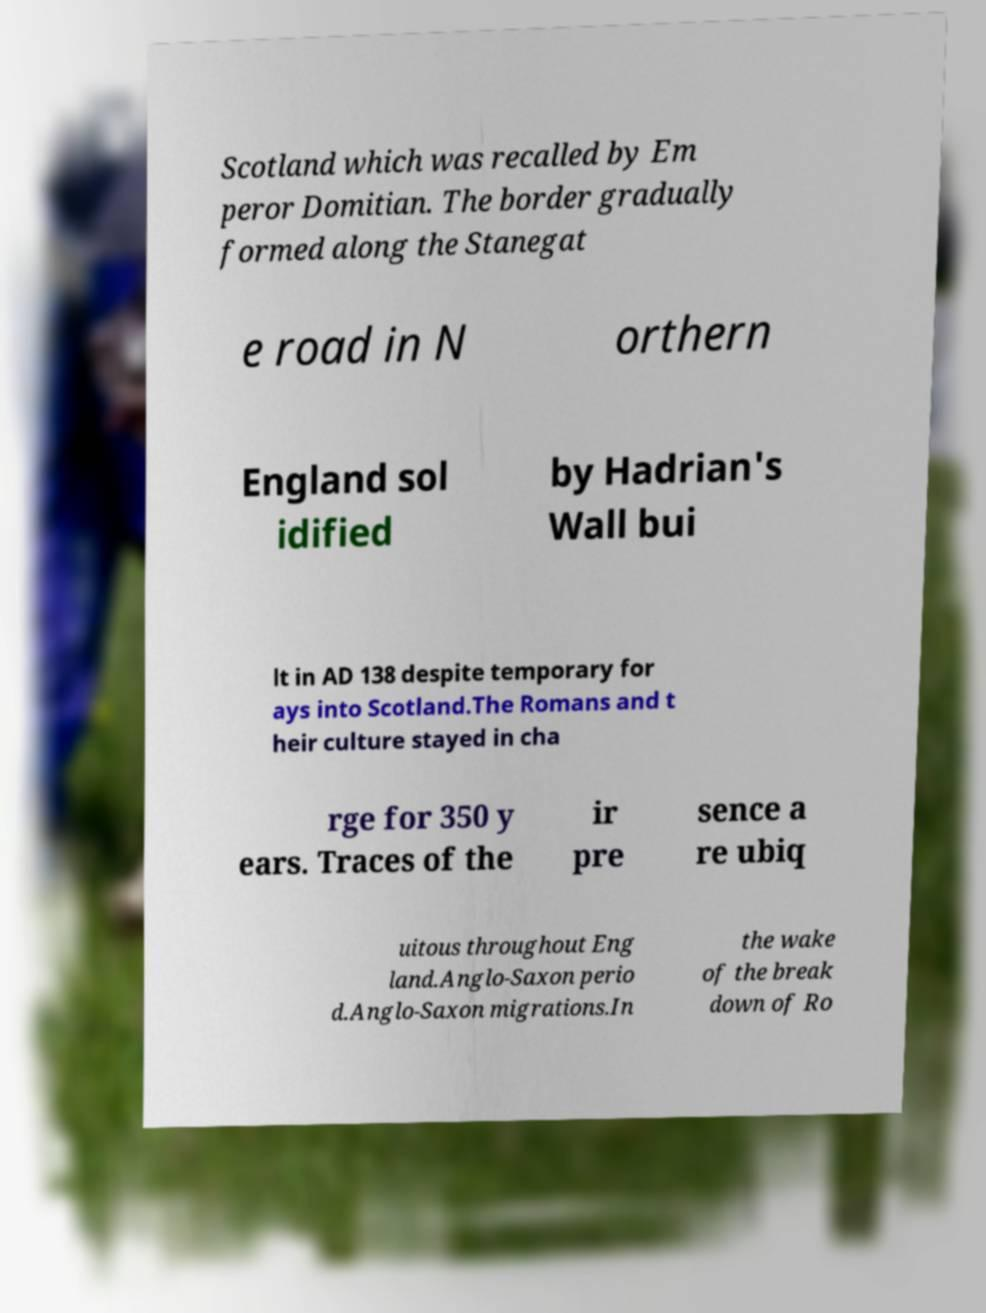There's text embedded in this image that I need extracted. Can you transcribe it verbatim? Scotland which was recalled by Em peror Domitian. The border gradually formed along the Stanegat e road in N orthern England sol idified by Hadrian's Wall bui lt in AD 138 despite temporary for ays into Scotland.The Romans and t heir culture stayed in cha rge for 350 y ears. Traces of the ir pre sence a re ubiq uitous throughout Eng land.Anglo-Saxon perio d.Anglo-Saxon migrations.In the wake of the break down of Ro 